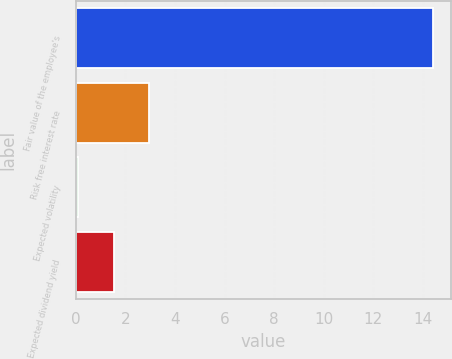<chart> <loc_0><loc_0><loc_500><loc_500><bar_chart><fcel>Fair value of the employee's<fcel>Risk free interest rate<fcel>Expected volatility<fcel>Expected dividend yield<nl><fcel>14.4<fcel>2.96<fcel>0.1<fcel>1.53<nl></chart> 